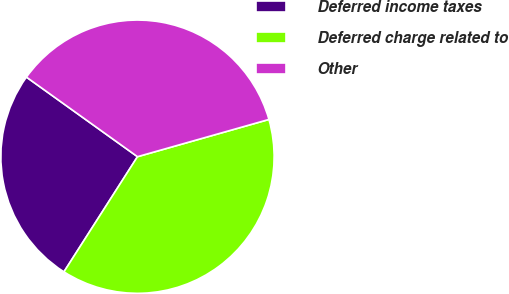Convert chart to OTSL. <chart><loc_0><loc_0><loc_500><loc_500><pie_chart><fcel>Deferred income taxes<fcel>Deferred charge related to<fcel>Other<nl><fcel>25.85%<fcel>38.44%<fcel>35.71%<nl></chart> 